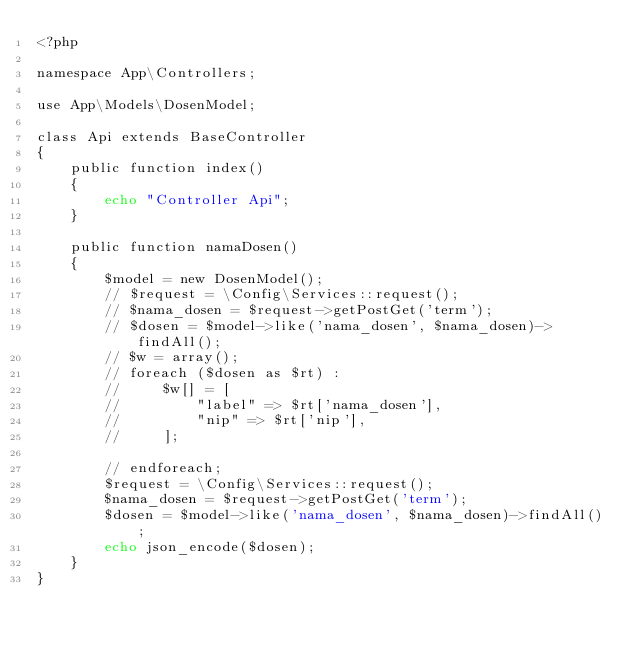Convert code to text. <code><loc_0><loc_0><loc_500><loc_500><_PHP_><?php

namespace App\Controllers;

use App\Models\DosenModel;

class Api extends BaseController
{
    public function index()
    {
        echo "Controller Api";
    }

    public function namaDosen()
    {
        $model = new DosenModel();
        // $request = \Config\Services::request();
        // $nama_dosen = $request->getPostGet('term');
        // $dosen = $model->like('nama_dosen', $nama_dosen)->findAll();
        // $w = array();
        // foreach ($dosen as $rt) :
        //     $w[] = [
        //         "label" => $rt['nama_dosen'],
        //         "nip" => $rt['nip'],
        //     ];

        // endforeach;
        $request = \Config\Services::request();
        $nama_dosen = $request->getPostGet('term');
        $dosen = $model->like('nama_dosen', $nama_dosen)->findAll();
        echo json_encode($dosen);
    }
}
</code> 